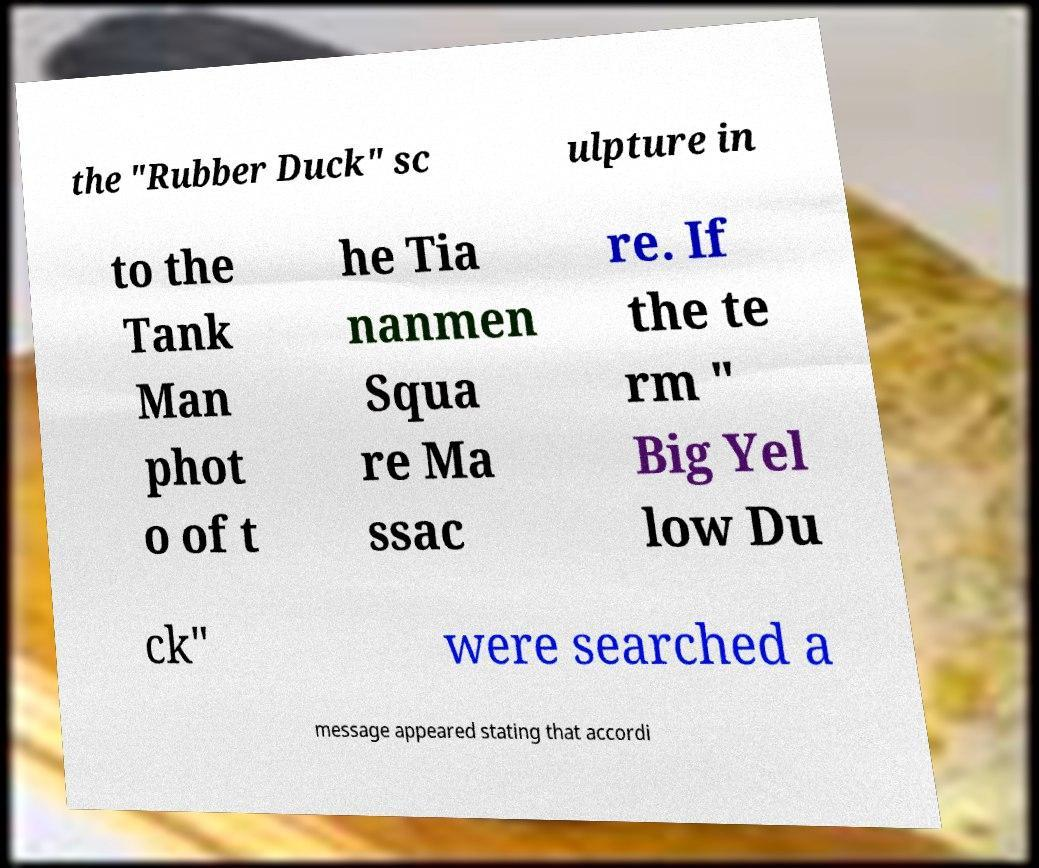I need the written content from this picture converted into text. Can you do that? the "Rubber Duck" sc ulpture in to the Tank Man phot o of t he Tia nanmen Squa re Ma ssac re. If the te rm " Big Yel low Du ck" were searched a message appeared stating that accordi 